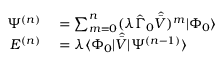<formula> <loc_0><loc_0><loc_500><loc_500>\begin{array} { r l } { \Psi ^ { ( n ) } } & = \sum _ { m = 0 } ^ { n } ( \lambda \hat { \Gamma } _ { 0 } \hat { \bar { V } } ) ^ { m } | \Phi _ { 0 } \rangle } \\ { E ^ { ( n ) } } & = \lambda \langle \Phi _ { 0 } | \hat { \bar { V } } | \Psi ^ { ( n - 1 ) } \rangle } \end{array}</formula> 